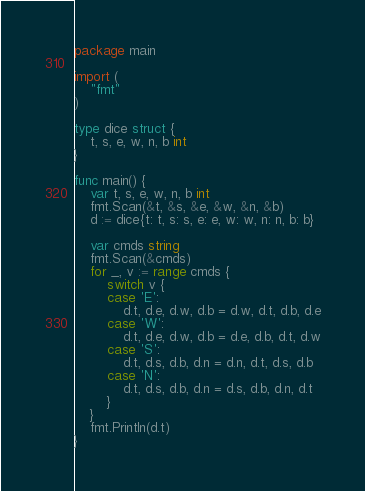Convert code to text. <code><loc_0><loc_0><loc_500><loc_500><_Go_>package main
 
import (
    "fmt"
)
 
type dice struct {
    t, s, e, w, n, b int
}
 
func main() {
    var t, s, e, w, n, b int
    fmt.Scan(&t, &s, &e, &w, &n, &b)
    d := dice{t: t, s: s, e: e, w: w, n: n, b: b}
 
    var cmds string
    fmt.Scan(&cmds)
    for _, v := range cmds {
        switch v {
        case 'E':
            d.t, d.e, d.w, d.b = d.w, d.t, d.b, d.e
        case 'W':
            d.t, d.e, d.w, d.b = d.e, d.b, d.t, d.w
        case 'S':
            d.t, d.s, d.b, d.n = d.n, d.t, d.s, d.b
        case 'N':
            d.t, d.s, d.b, d.n = d.s, d.b, d.n, d.t
        }
    }
    fmt.Println(d.t)
}
</code> 